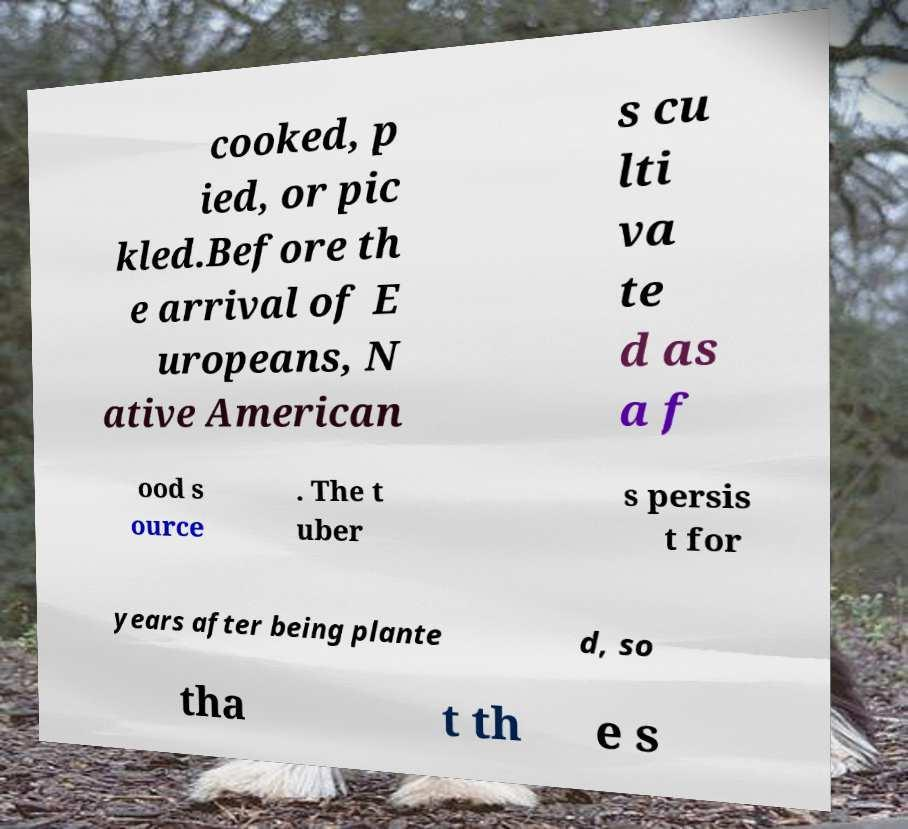Please read and relay the text visible in this image. What does it say? cooked, p ied, or pic kled.Before th e arrival of E uropeans, N ative American s cu lti va te d as a f ood s ource . The t uber s persis t for years after being plante d, so tha t th e s 